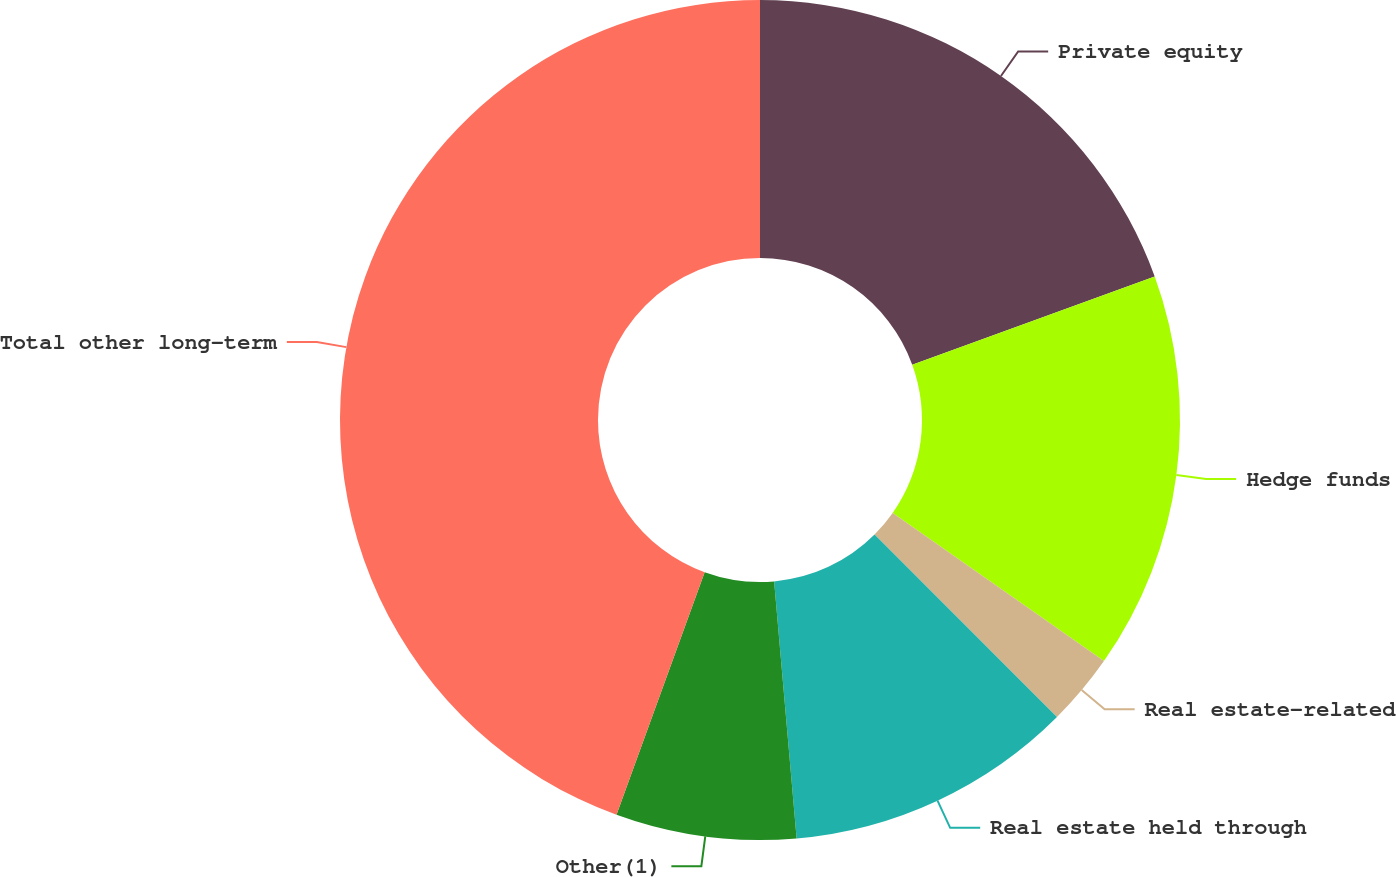<chart> <loc_0><loc_0><loc_500><loc_500><pie_chart><fcel>Private equity<fcel>Hedge funds<fcel>Real estate-related<fcel>Real estate held through<fcel>Other(1)<fcel>Total other long-term<nl><fcel>19.45%<fcel>15.28%<fcel>2.77%<fcel>11.11%<fcel>6.94%<fcel>44.45%<nl></chart> 